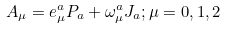<formula> <loc_0><loc_0><loc_500><loc_500>A _ { \mu } = e _ { \mu } ^ { a } P _ { a } + \omega _ { \mu } ^ { a } J _ { a } ; \mu = 0 , 1 , 2</formula> 